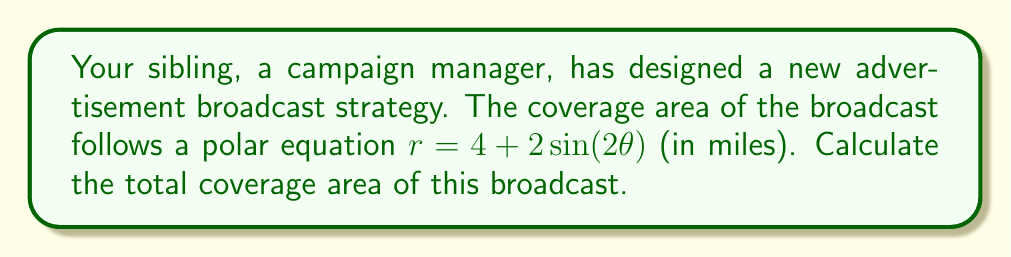Provide a solution to this math problem. To find the area enclosed by a polar curve, we can use the formula:

$$ A = \frac{1}{2} \int_{0}^{2\pi} r^2(\theta) d\theta $$

Where $r(\theta)$ is our given polar equation. Let's solve this step-by-step:

1) First, we square our $r(\theta)$ function:
   $r^2 = (4 + 2\sin(2\theta))^2 = 16 + 16\sin(2\theta) + 4\sin^2(2\theta)$

2) Now we set up our integral:
   $$ A = \frac{1}{2} \int_{0}^{2\pi} (16 + 16\sin(2\theta) + 4\sin^2(2\theta)) d\theta $$

3) Let's integrate each term separately:
   - $\int_{0}^{2\pi} 16 d\theta = 16\theta |_{0}^{2\pi} = 32\pi$
   - $\int_{0}^{2\pi} 16\sin(2\theta) d\theta = -8\cos(2\theta) |_{0}^{2\pi} = 0$
   - $\int_{0}^{2\pi} 4\sin^2(2\theta) d\theta = 2\theta - \sin(4\theta)/2 |_{0}^{2\pi} = 4\pi$

4) Adding these results:
   $$ A = \frac{1}{2} (32\pi + 0 + 4\pi) = 18\pi $$

Therefore, the total coverage area is $18\pi$ square miles.
Answer: $18\pi$ square miles 